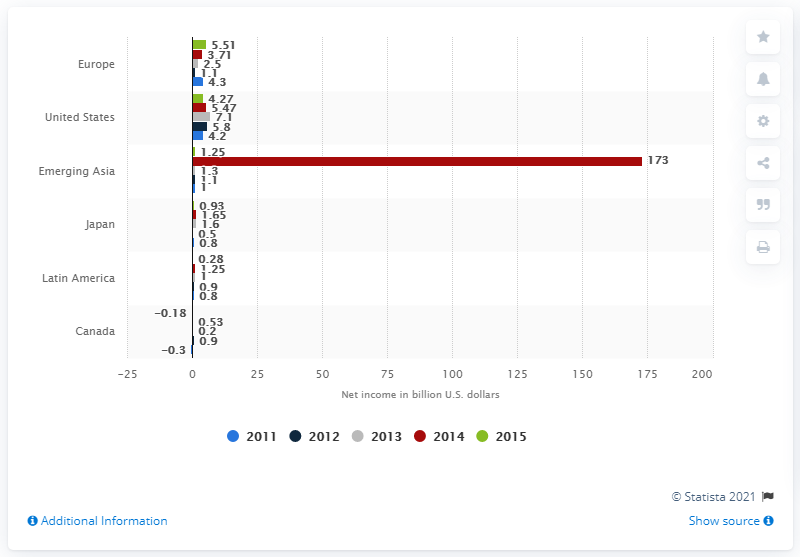Mention a couple of crucial points in this snapshot. The net income of the top 100 companies in Europe in 2011 was 4.3 billion euros. 